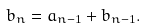<formula> <loc_0><loc_0><loc_500><loc_500>b _ { n } = a _ { n - 1 } + b _ { n - 1 } .</formula> 